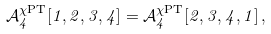<formula> <loc_0><loc_0><loc_500><loc_500>\mathcal { A } _ { 4 } ^ { \chi \text {PT} } [ 1 , 2 , 3 , 4 ] = \mathcal { A } _ { 4 } ^ { \chi \text {PT} } [ 2 , 3 , 4 , 1 ] \, ,</formula> 